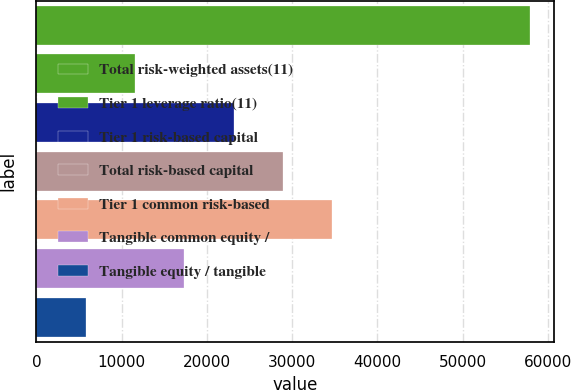Convert chart. <chart><loc_0><loc_0><loc_500><loc_500><bar_chart><fcel>Total risk-weighted assets(11)<fcel>Tier 1 leverage ratio(11)<fcel>Tier 1 risk-based capital<fcel>Total risk-based capital<fcel>Tier 1 common risk-based<fcel>Tangible common equity /<fcel>Tangible equity / tangible<nl><fcel>57850<fcel>11576.3<fcel>23144.8<fcel>28929<fcel>34713.2<fcel>17360.5<fcel>5792.12<nl></chart> 